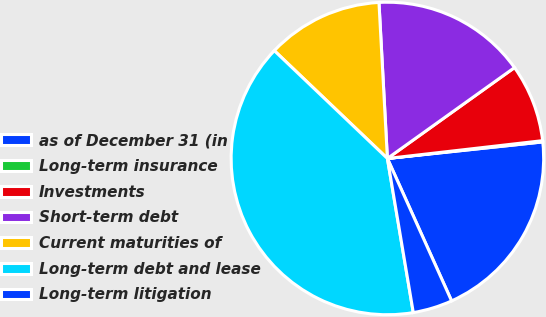Convert chart to OTSL. <chart><loc_0><loc_0><loc_500><loc_500><pie_chart><fcel>as of December 31 (in<fcel>Long-term insurance<fcel>Investments<fcel>Short-term debt<fcel>Current maturities of<fcel>Long-term debt and lease<fcel>Long-term litigation<nl><fcel>19.95%<fcel>0.13%<fcel>8.06%<fcel>15.98%<fcel>12.02%<fcel>39.77%<fcel>4.09%<nl></chart> 